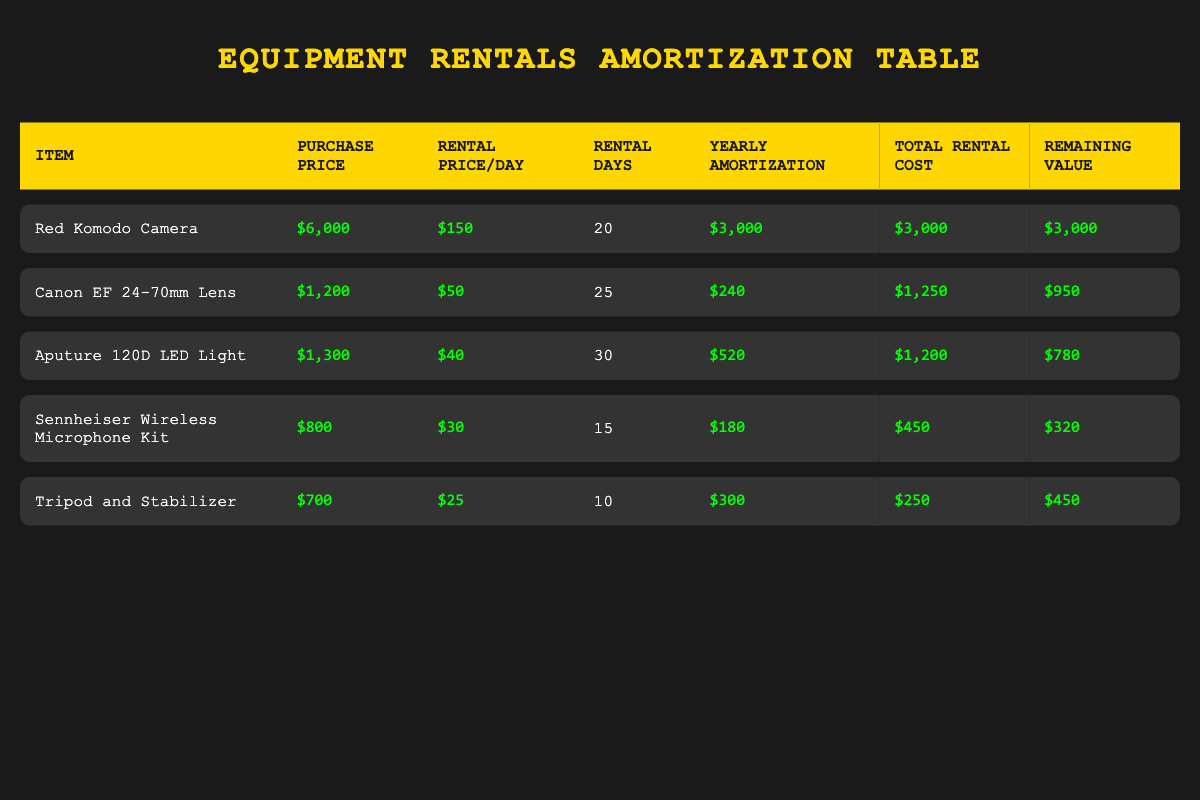What is the total rental cost for the Red Komodo Camera? The table lists the total rental cost for the Red Komodo Camera as $3,000.
Answer: $3,000 How many days was the Canon EF 24-70mm Lens rented? The table shows that the Canon EF 24-70mm Lens was rented for 25 days.
Answer: 25 days Which item has the highest remaining value after rental? By comparing the remaining values, the Red Komodo Camera has a remaining value of $3,000, which is higher than the values of other items.
Answer: Red Komodo Camera What is the total rental cost of all equipment combined? To find the total rental cost, we sum the total rental costs for all items: $3,000 + $1,250 + $1,200 + $450 + $250 = $6,150.
Answer: $6,150 Is the yearly amortization for the Aputure 120D LED Light higher than that of the Sennheiser Wireless Microphone Kit? The yearly amortization for the Aputure 120D LED Light is $520, while for the Sennheiser Wireless Microphone Kit, it is $180. Since $520 is greater than $180, the statement is true.
Answer: Yes What is the average remaining value of the rental equipment? First, we find the remaining values of all items: $3,000 + $950 + $780 + $320 + $450 = $5,500. The average is then $5,500 divided by 5 items, which equals $1,100.
Answer: $1,100 Did any equipment have a total rental cost greater than its yearly amortization? The total rental cost and yearly amortization for each item were compared. The Red Komodo Camera's total rental cost ($3,000) exceeds its yearly amortization ($3,000) when it's the same, showing that multiple items (e.g., Aputure 120D LED Light) exceed theirs. Thus, the answer is yes.
Answer: Yes Which item has the lowest purchase price? By examining the purchase prices, the Tripod and Stabilizer has the lowest purchase price of $700, compared to other items.
Answer: Tripod and Stabilizer How much more was the yearly amortization for the Red Komodo Camera compared to the Canon EF 24-70mm Lens? The yearly amortization for the Red Komodo Camera is $3,000, while the Canon EF 24-70mm Lens is $240. The difference is $3,000 - $240 = $2,760.
Answer: $2,760 